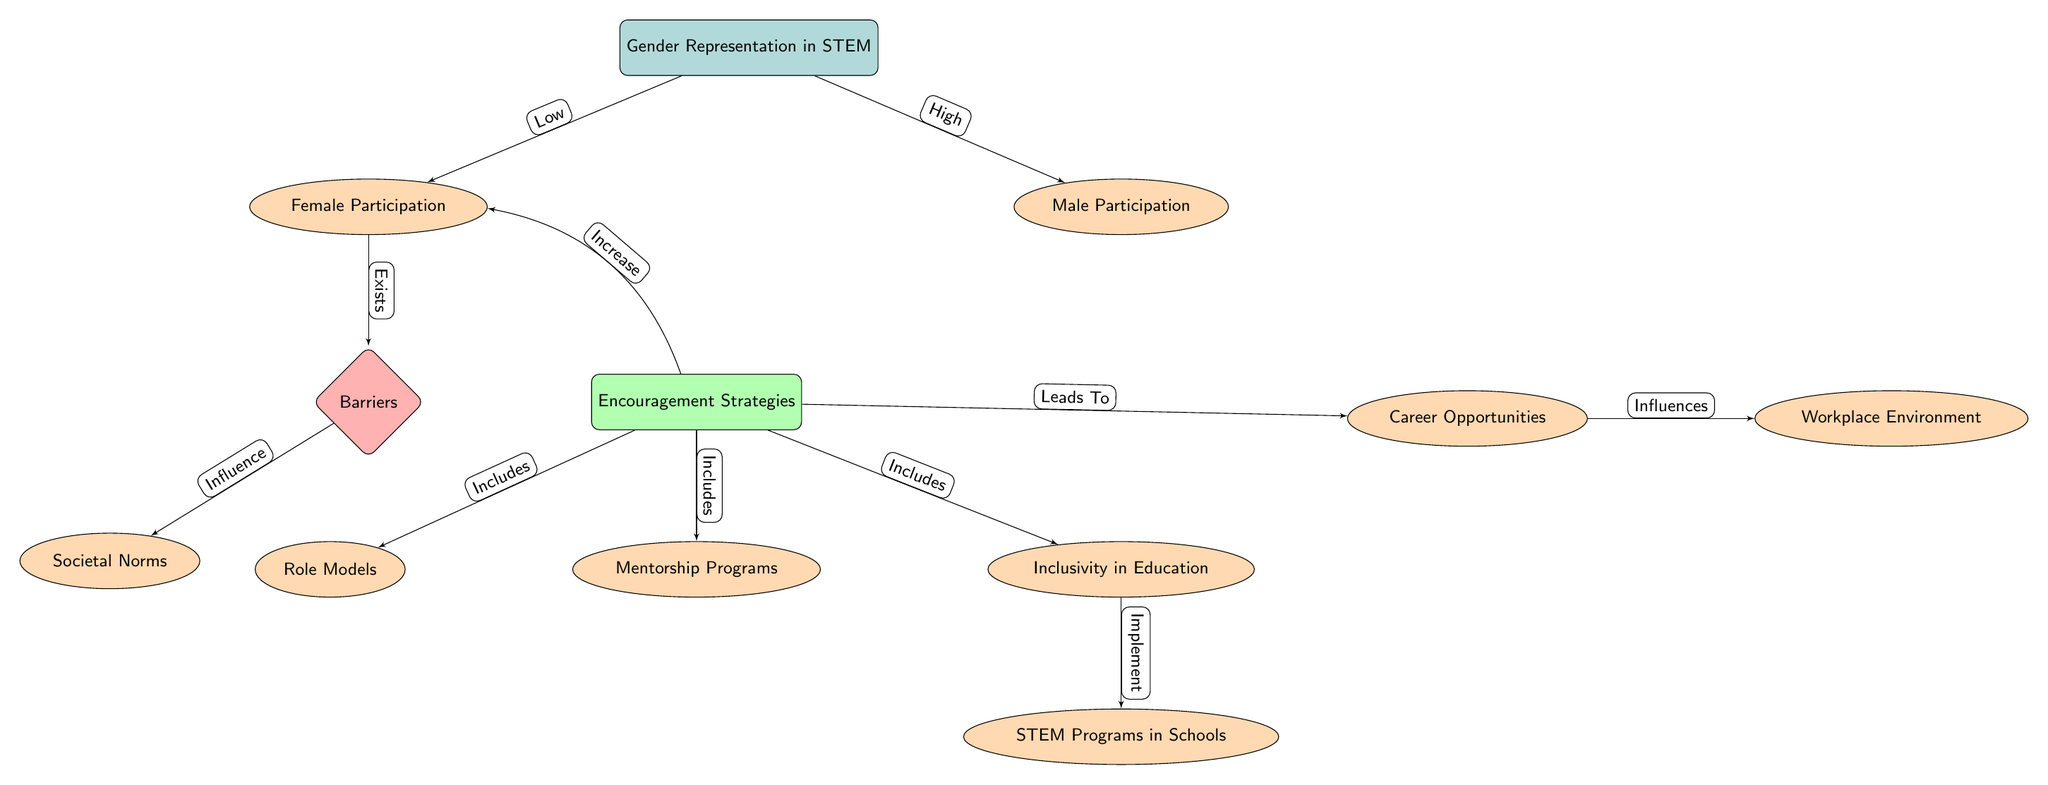What is the main topic of the diagram? The title of the main node clearly states the focus of the diagram, which is “Gender Representation in STEM.”
Answer: Gender Representation in STEM How many sub-nodes are connected to the main node? By counting the sub-nodes branching from the main node, we find there are two: Female Participation and Male Participation.
Answer: 2 Which node represents the barriers to female participation? The diagram specifies the node that directly connects to Female Participation and is labeled as “Barriers.”
Answer: Barriers What kind of strategies are included in the Encouragement Strategies node? By looking at the connections from the Encouragement Strategies node, we can identify that it includes Mentorship Programs, Inclusivity in Education, and Role Models, among others.
Answer: Mentorship Programs, Inclusivity in Education, Role Models How does the node Workplace Environment relate to Career Opportunities? The diagram shows a directional relationship where Career Opportunities leads to Workplace Environment, indicating that the former has an influence on the latter.
Answer: Influences What barriers influence Female Participation according to the diagram? The sub-node under Female Participation that affects it is linked to the Societal Norms barrier, indicating that these norms are barriers to female participation in STEM.
Answer: Societal Norms Which node does the Encouragement Strategies node lead to that discusses school interventions? Upon reviewing the connections from the Encouragement Strategies node, it is clear that it leads to the node labeled STEM Programs in Schools, which discusses school interventions.
Answer: STEM Programs in Schools What is the relationship between Career Opportunities and Workplace Environment? The diagram indicates a causal relationship where Career Opportunities influences the Workplace Environment, meaning changes in career opportunities affect workplace conditions.
Answer: Influences 